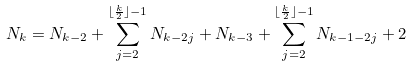<formula> <loc_0><loc_0><loc_500><loc_500>N _ { k } = N _ { k - 2 } + \sum _ { j = 2 } ^ { \lfloor \frac { k } { 2 } \rfloor - 1 } N _ { k - 2 j } + N _ { k - 3 } + \sum _ { j = 2 } ^ { \lfloor \frac { k } { 2 } \rfloor - 1 } N _ { k - 1 - 2 j } + 2</formula> 